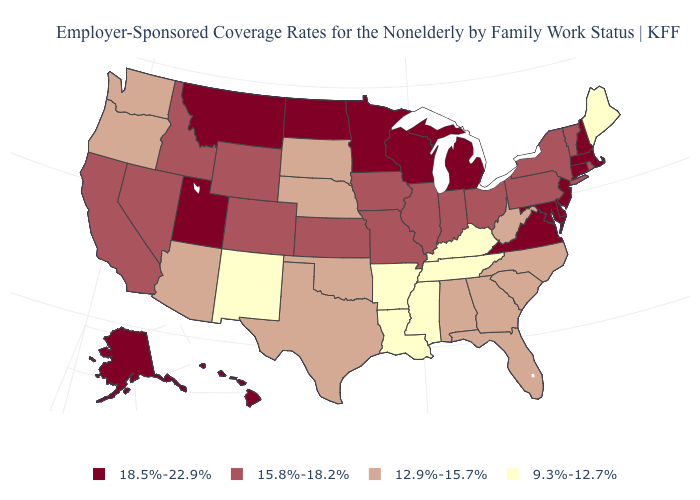What is the highest value in the MidWest ?
Concise answer only. 18.5%-22.9%. Is the legend a continuous bar?
Short answer required. No. Name the states that have a value in the range 9.3%-12.7%?
Concise answer only. Arkansas, Kentucky, Louisiana, Maine, Mississippi, New Mexico, Tennessee. Among the states that border Texas , does New Mexico have the highest value?
Write a very short answer. No. What is the highest value in the USA?
Short answer required. 18.5%-22.9%. Among the states that border Vermont , does New York have the lowest value?
Give a very brief answer. Yes. Does Mississippi have the highest value in the South?
Write a very short answer. No. Is the legend a continuous bar?
Quick response, please. No. Name the states that have a value in the range 9.3%-12.7%?
Concise answer only. Arkansas, Kentucky, Louisiana, Maine, Mississippi, New Mexico, Tennessee. What is the lowest value in the Northeast?
Keep it brief. 9.3%-12.7%. Does New Mexico have the lowest value in the USA?
Keep it brief. Yes. What is the highest value in the West ?
Be succinct. 18.5%-22.9%. Which states have the highest value in the USA?
Concise answer only. Alaska, Connecticut, Delaware, Hawaii, Maryland, Massachusetts, Michigan, Minnesota, Montana, New Hampshire, New Jersey, North Dakota, Utah, Virginia, Wisconsin. What is the lowest value in the South?
Give a very brief answer. 9.3%-12.7%. Among the states that border New Hampshire , does Vermont have the lowest value?
Concise answer only. No. 